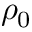Convert formula to latex. <formula><loc_0><loc_0><loc_500><loc_500>\rho _ { 0 }</formula> 